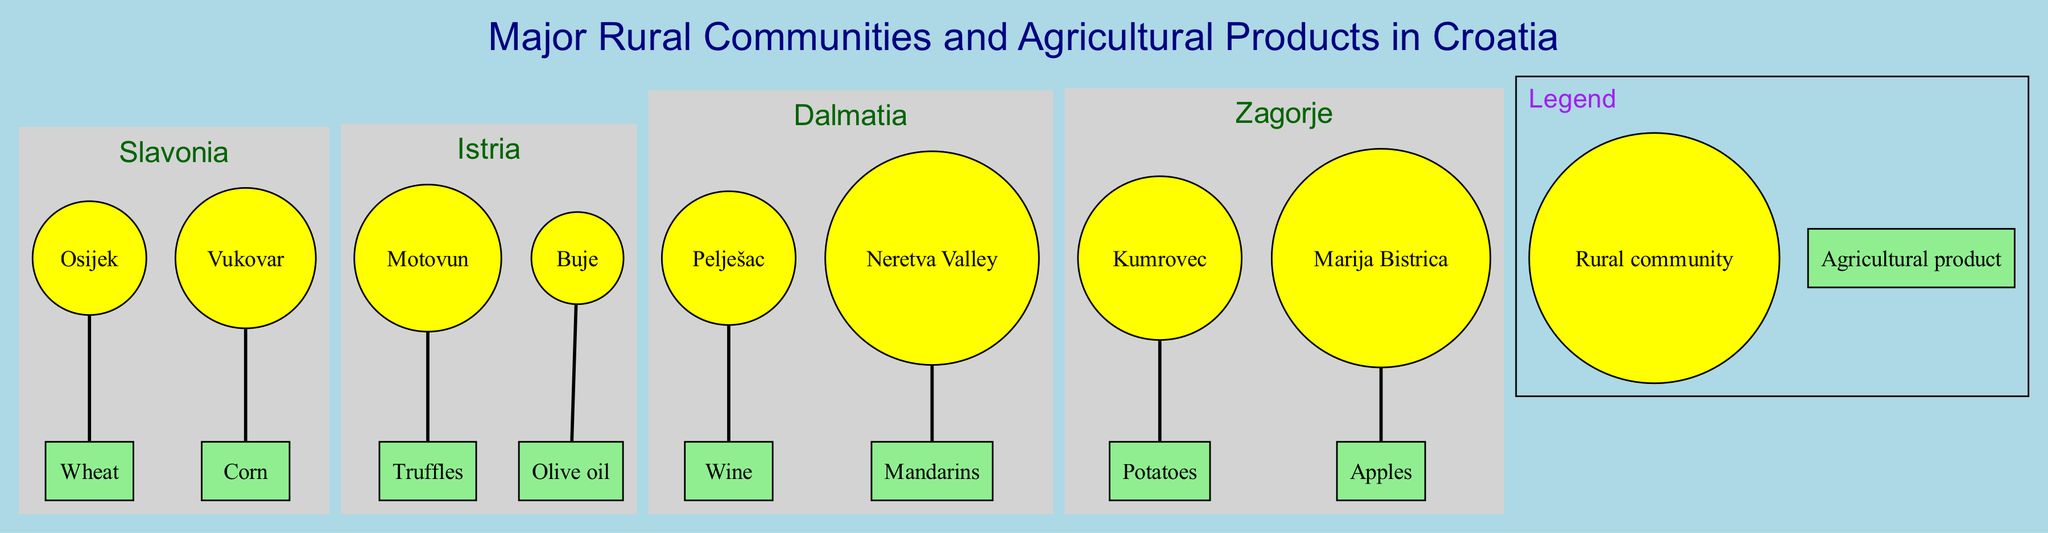What rural community in Slavonia produces wheat? The diagram indicates that Osijek is the rural community in the Slavonia region that produces wheat. By examining the nodes under the Slavonia subgraph, we see that Osijek is connected directly to the wheat product node.
Answer: Osijek Which primary agricultural product is associated with Motovun? Looking at the Istria subgraph, the community of Motovun is linked to the product node representing truffles. Thus, Motovun produces truffles.
Answer: Truffles How many major rural communities are highlighted on the map? The diagram includes four regions, each containing two rural communities. Counting all the communities (Osijek, Vukovar, Motovun, Buje, Pelješac, Neretva Valley, Kumrovec, and Marija Bistrica), there is a total of eight communities indicated in the diagram.
Answer: 8 Which community in Dalmatia produces mandarins? The Neretva Valley community is shown in the diagram as the producer of mandarins within the Dalmatia region. By following the connection from the community node to its respective product node, it is confirmed that Neretva Valley is associated with mandarins.
Answer: Neretva Valley What color represents the rural communities on the diagram? The diagram specifically denotes rural communities with a yellow fill color in their node representation. This can be observed in each of the community nodes throughout the regions on the map.
Answer: Yellow Which region contains the community of Kumrovec? By checking the Zagorje subgraph, we can identify that the community of Kumrovec is located within the Zagorje region on the map. This region is visually grouped and clearly labeled in the diagram.
Answer: Zagorje What type of agricultural product does Buje produce? The Buje community is directly associated with the product node indicating olive oil, which shows that Buje produces olive oil. This information is gained by examining the connections between nodes in the Istria region.
Answer: Olive oil How many connections (edges) are depicted in the diagram? The diagram illustrates a total of eight connections, which can be counted by examining each community's link to its primary agricultural product across all the regions. Each of the eight communities has a direct link to its respective product.
Answer: 8 